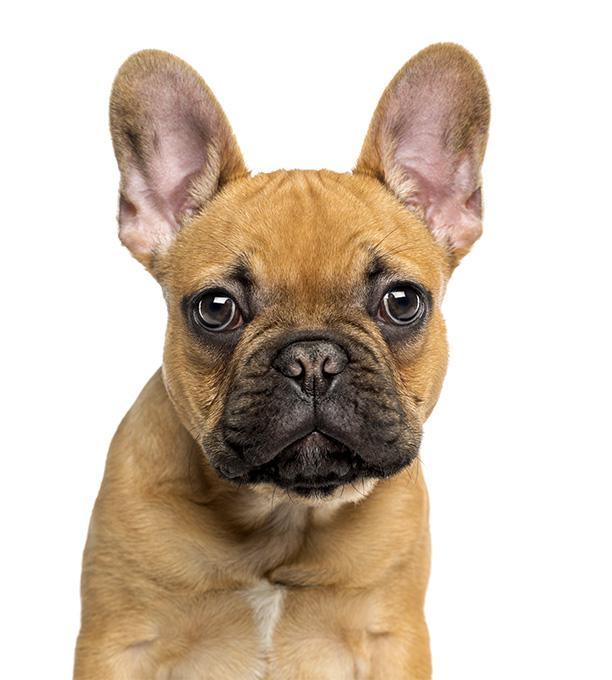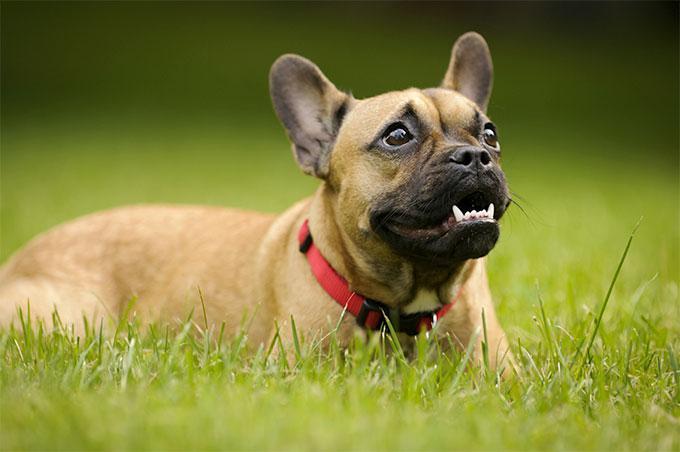The first image is the image on the left, the second image is the image on the right. For the images displayed, is the sentence "One image shows a black and white dog on a field scattered with wild flowers." factually correct? Answer yes or no. No. 